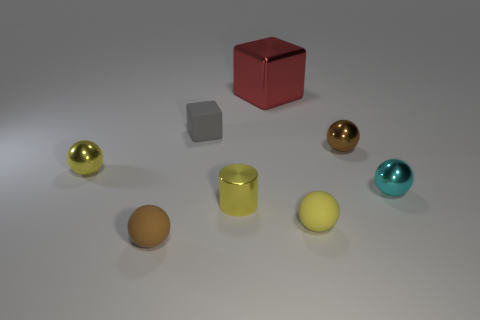What number of small things are either yellow things or brown objects?
Provide a short and direct response. 5. How many small balls have the same material as the big red cube?
Give a very brief answer. 3. How big is the brown thing that is to the left of the tiny yellow rubber sphere?
Offer a very short reply. Small. What shape is the brown object behind the brown ball that is in front of the tiny cyan metal thing?
Offer a very short reply. Sphere. There is a brown object that is in front of the brown thing that is on the right side of the tiny rubber cube; what number of yellow metal objects are to the left of it?
Give a very brief answer. 1. Are there fewer brown metallic spheres that are in front of the brown matte sphere than gray cubes?
Offer a terse response. Yes. Is there any other thing that has the same shape as the small brown rubber object?
Your answer should be compact. Yes. There is a small yellow object behind the cyan object; what is its shape?
Provide a succinct answer. Sphere. There is a thing that is behind the tiny block in front of the red thing that is left of the yellow matte object; what shape is it?
Offer a very short reply. Cube. What number of objects are either tiny cylinders or big yellow matte cylinders?
Your answer should be compact. 1. 